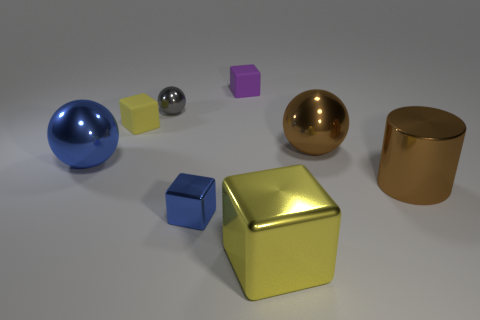There is a thing that is the same color as the shiny cylinder; what material is it?
Your response must be concise. Metal. Does the large object left of the big metallic cube have the same color as the tiny metallic sphere?
Make the answer very short. No. There is a thing that is both in front of the small gray shiny thing and behind the large brown shiny ball; what color is it?
Offer a very short reply. Yellow. There is a yellow shiny object that is the same size as the brown cylinder; what is its shape?
Offer a very short reply. Cube. Are there any small purple objects of the same shape as the tiny gray shiny thing?
Give a very brief answer. No. Is the size of the shiny block that is to the left of the yellow metal thing the same as the purple rubber cube?
Provide a short and direct response. Yes. There is a block that is both behind the big brown ball and in front of the purple cube; what is its size?
Offer a terse response. Small. How many other things are there of the same material as the gray object?
Your answer should be compact. 5. How big is the shiny ball to the left of the yellow matte thing?
Your response must be concise. Large. Is the color of the small sphere the same as the cylinder?
Offer a very short reply. No. 